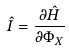Convert formula to latex. <formula><loc_0><loc_0><loc_500><loc_500>\hat { I } = \frac { \partial \hat { H } } { \partial \Phi _ { X } }</formula> 